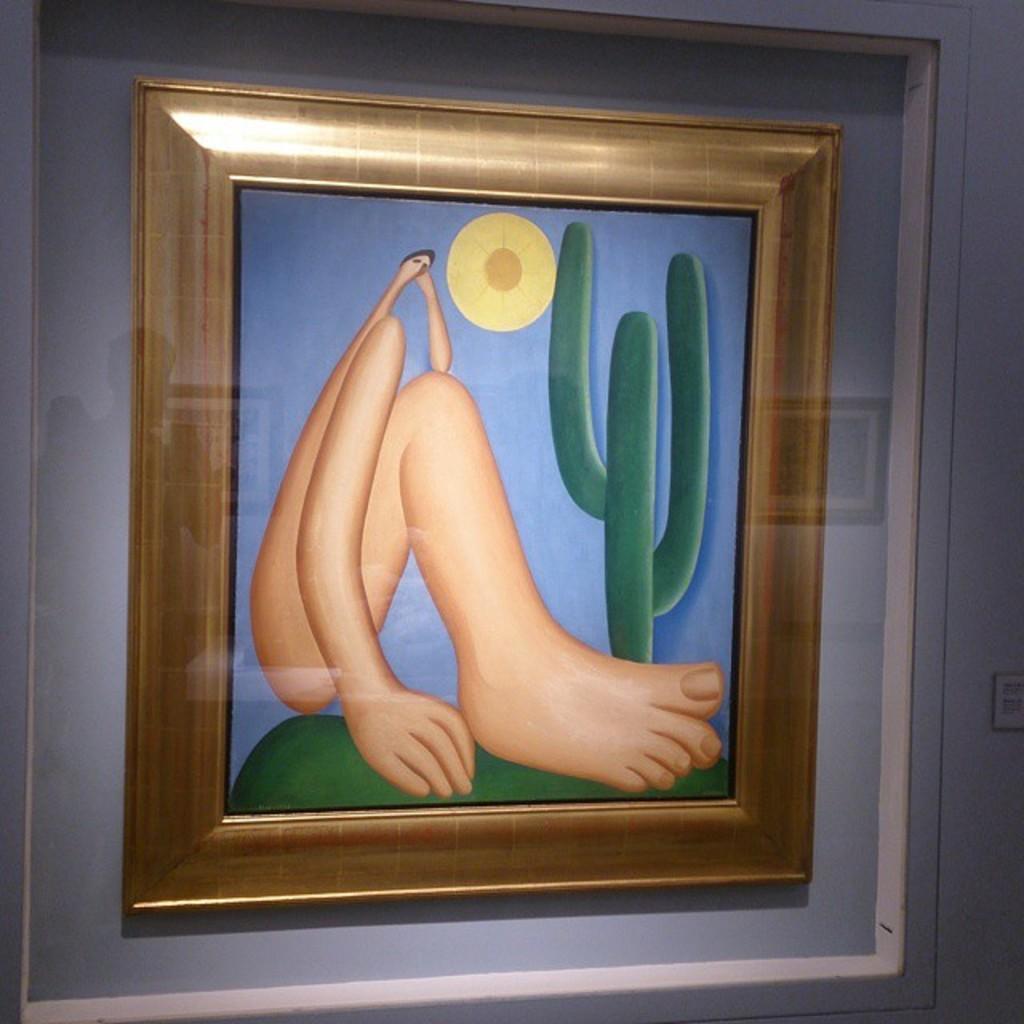Please provide a concise description of this image. In this image there is a frame which consists of painting of a leg and a plant. This frame is attached to a wall. 